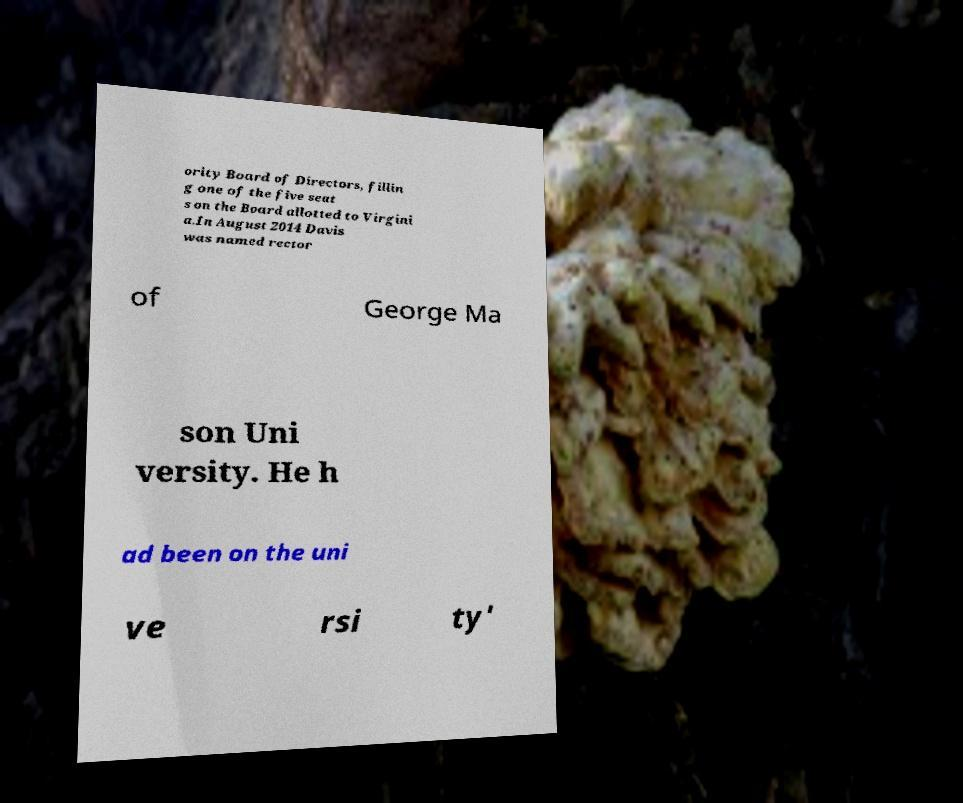Please identify and transcribe the text found in this image. ority Board of Directors, fillin g one of the five seat s on the Board allotted to Virgini a.In August 2014 Davis was named rector of George Ma son Uni versity. He h ad been on the uni ve rsi ty' 